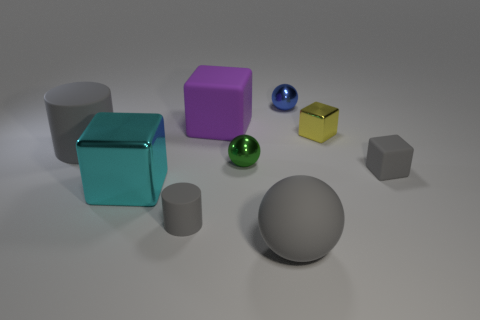Subtract 1 cubes. How many cubes are left? 3 Add 1 big red cylinders. How many objects exist? 10 Subtract all cylinders. How many objects are left? 7 Subtract 0 yellow cylinders. How many objects are left? 9 Subtract all big purple blocks. Subtract all small blue objects. How many objects are left? 7 Add 2 large gray spheres. How many large gray spheres are left? 3 Add 9 purple blocks. How many purple blocks exist? 10 